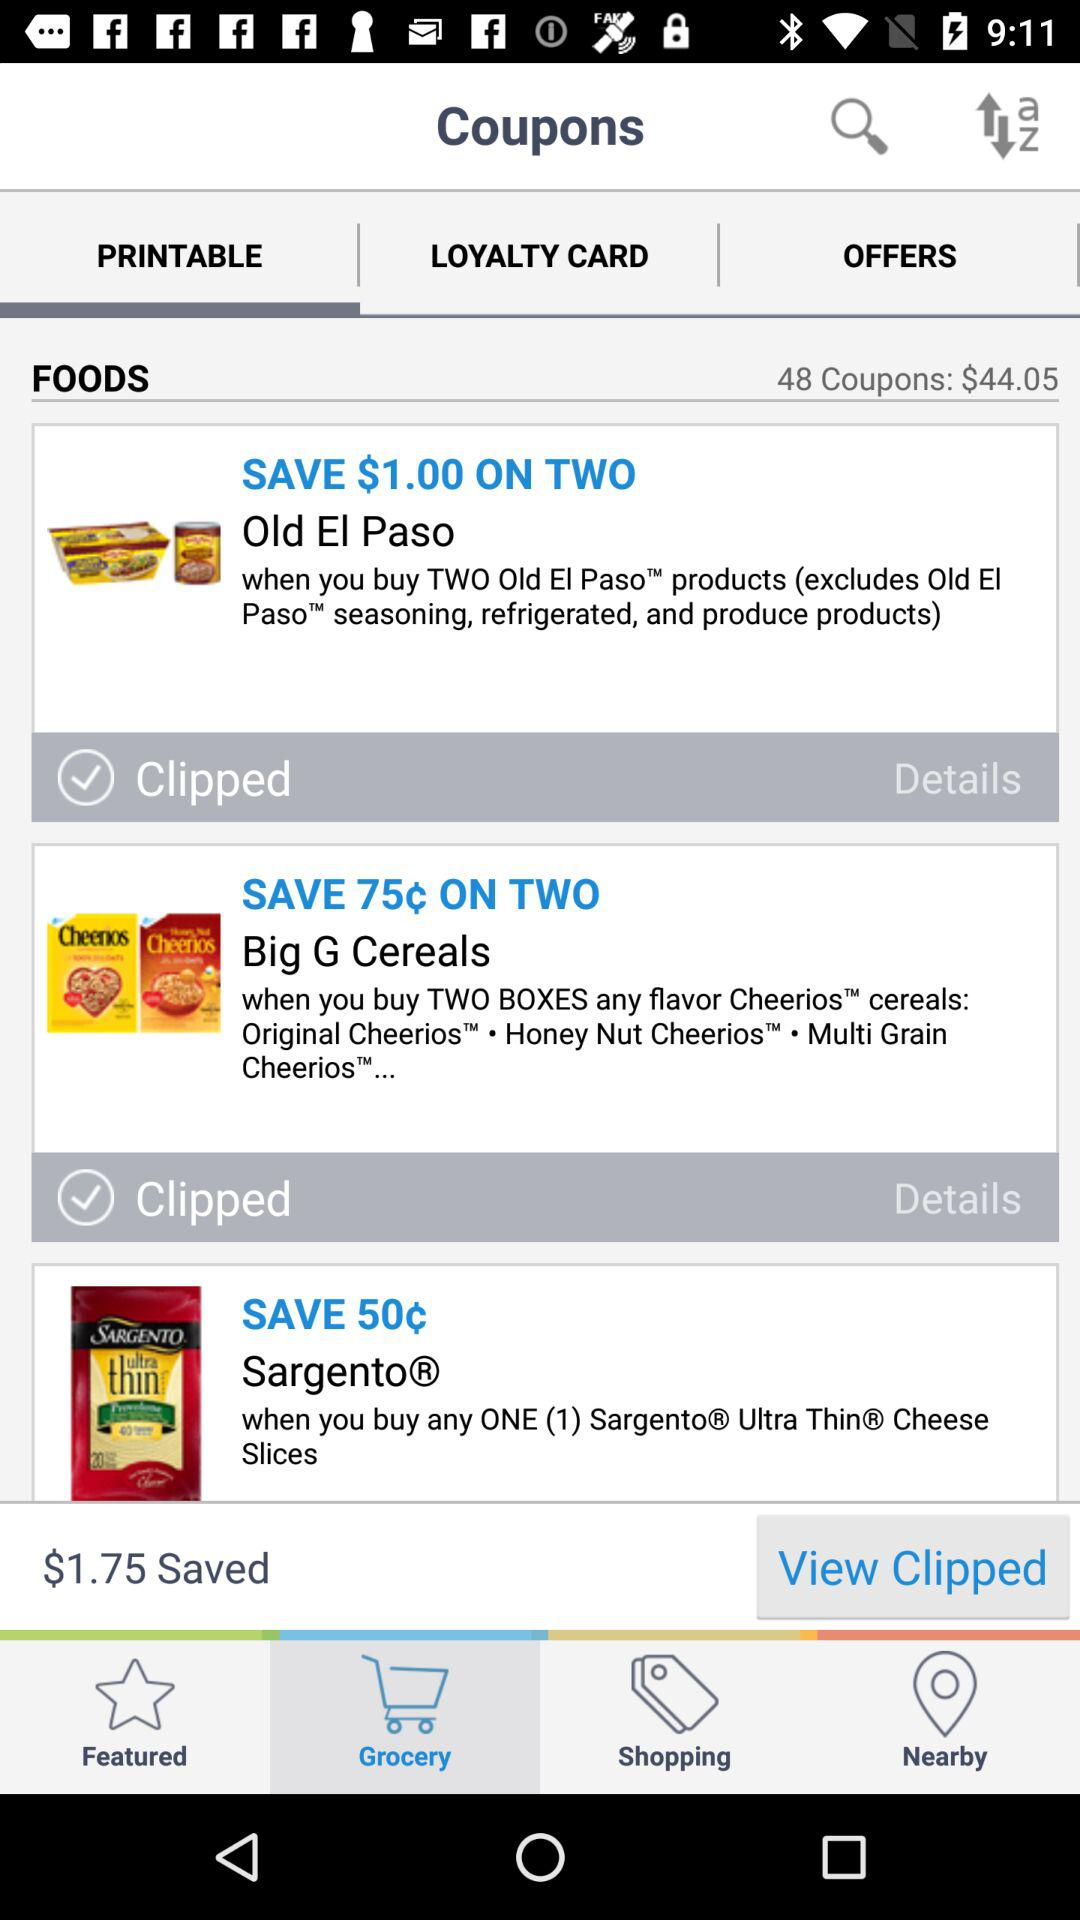Which tab is selected? The selected tab is "PRINTABLE". 